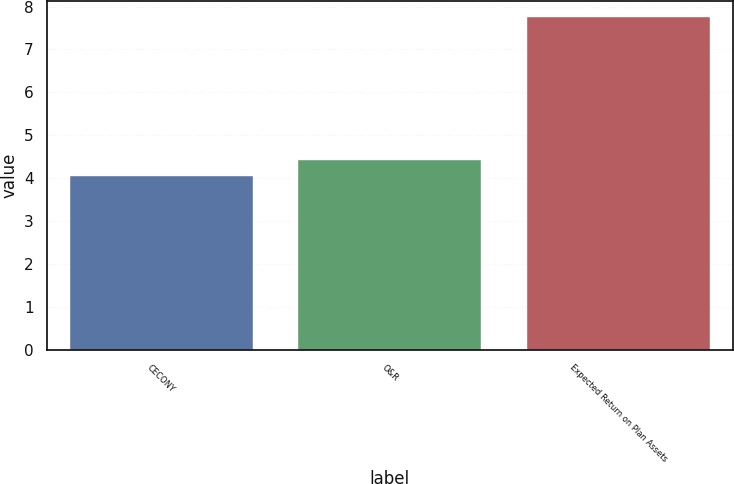<chart> <loc_0><loc_0><loc_500><loc_500><bar_chart><fcel>CECONY<fcel>O&R<fcel>Expected Return on Plan Assets<nl><fcel>4.05<fcel>4.42<fcel>7.75<nl></chart> 